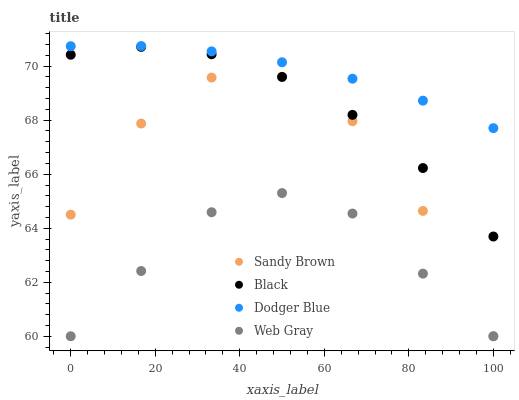Does Web Gray have the minimum area under the curve?
Answer yes or no. Yes. Does Dodger Blue have the maximum area under the curve?
Answer yes or no. Yes. Does Sandy Brown have the minimum area under the curve?
Answer yes or no. No. Does Sandy Brown have the maximum area under the curve?
Answer yes or no. No. Is Dodger Blue the smoothest?
Answer yes or no. Yes. Is Sandy Brown the roughest?
Answer yes or no. Yes. Is Web Gray the smoothest?
Answer yes or no. No. Is Web Gray the roughest?
Answer yes or no. No. Does Web Gray have the lowest value?
Answer yes or no. Yes. Does Dodger Blue have the lowest value?
Answer yes or no. No. Does Dodger Blue have the highest value?
Answer yes or no. Yes. Does Sandy Brown have the highest value?
Answer yes or no. No. Is Black less than Dodger Blue?
Answer yes or no. Yes. Is Dodger Blue greater than Sandy Brown?
Answer yes or no. Yes. Does Web Gray intersect Sandy Brown?
Answer yes or no. Yes. Is Web Gray less than Sandy Brown?
Answer yes or no. No. Is Web Gray greater than Sandy Brown?
Answer yes or no. No. Does Black intersect Dodger Blue?
Answer yes or no. No. 